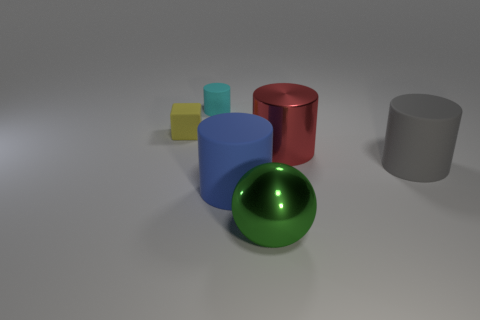Subtract all gray cylinders. How many cylinders are left? 3 Subtract all gray cylinders. How many cylinders are left? 3 Add 1 brown cylinders. How many objects exist? 7 Subtract all yellow cylinders. Subtract all red cubes. How many cylinders are left? 4 Subtract all cylinders. How many objects are left? 2 Subtract 0 gray balls. How many objects are left? 6 Subtract all tiny objects. Subtract all big blocks. How many objects are left? 4 Add 3 large gray rubber cylinders. How many large gray rubber cylinders are left? 4 Add 1 large green balls. How many large green balls exist? 2 